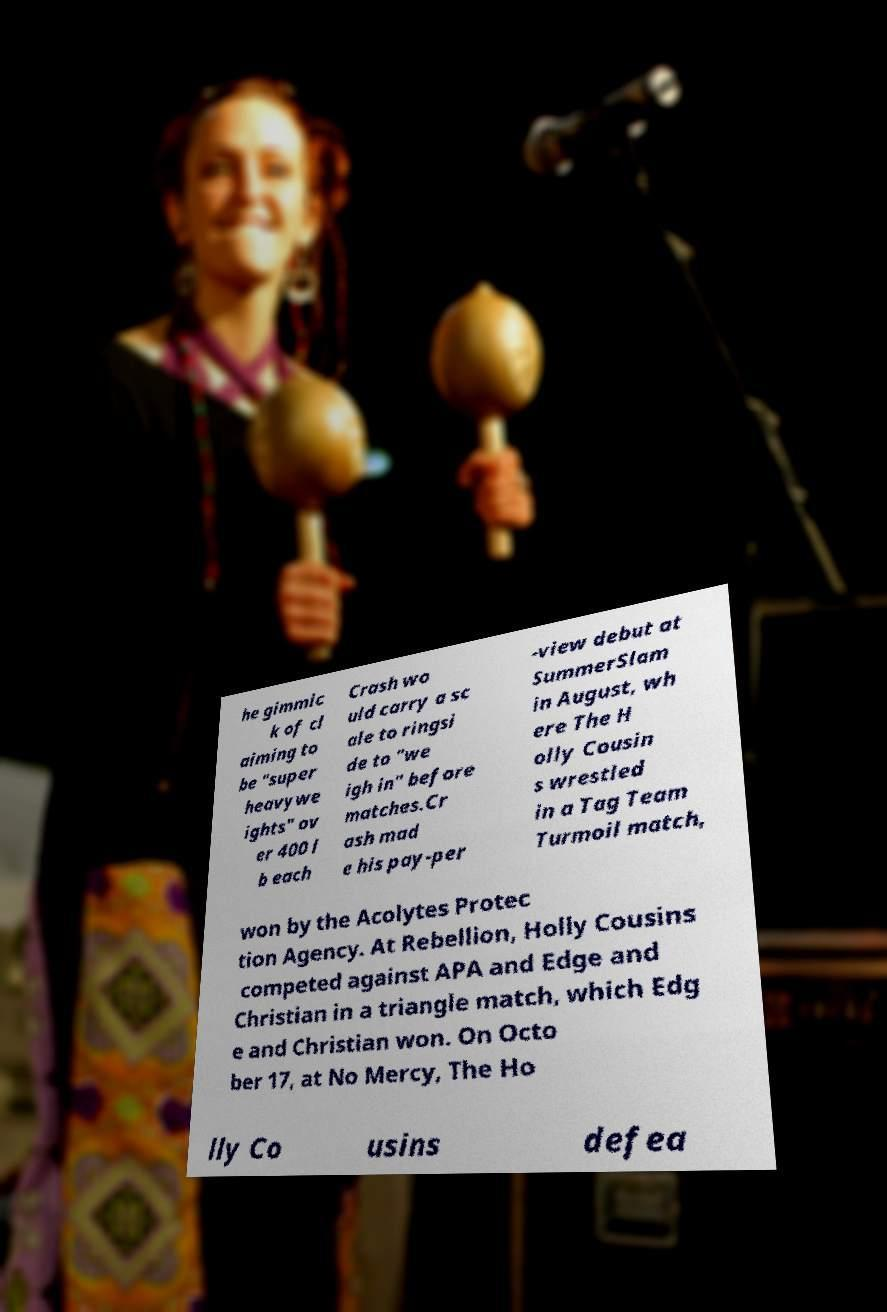I need the written content from this picture converted into text. Can you do that? he gimmic k of cl aiming to be "super heavywe ights" ov er 400 l b each Crash wo uld carry a sc ale to ringsi de to "we igh in" before matches.Cr ash mad e his pay-per -view debut at SummerSlam in August, wh ere The H olly Cousin s wrestled in a Tag Team Turmoil match, won by the Acolytes Protec tion Agency. At Rebellion, Holly Cousins competed against APA and Edge and Christian in a triangle match, which Edg e and Christian won. On Octo ber 17, at No Mercy, The Ho lly Co usins defea 